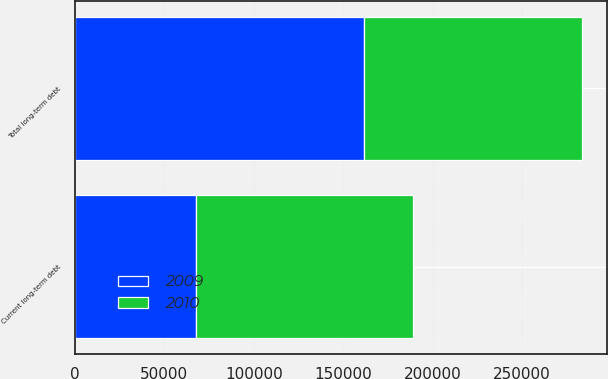Convert chart to OTSL. <chart><loc_0><loc_0><loc_500><loc_500><stacked_bar_chart><ecel><fcel>Current long-term debt<fcel>Total long-term debt<nl><fcel>2010<fcel>121689<fcel>121689<nl><fcel>2009<fcel>67545<fcel>161736<nl></chart> 